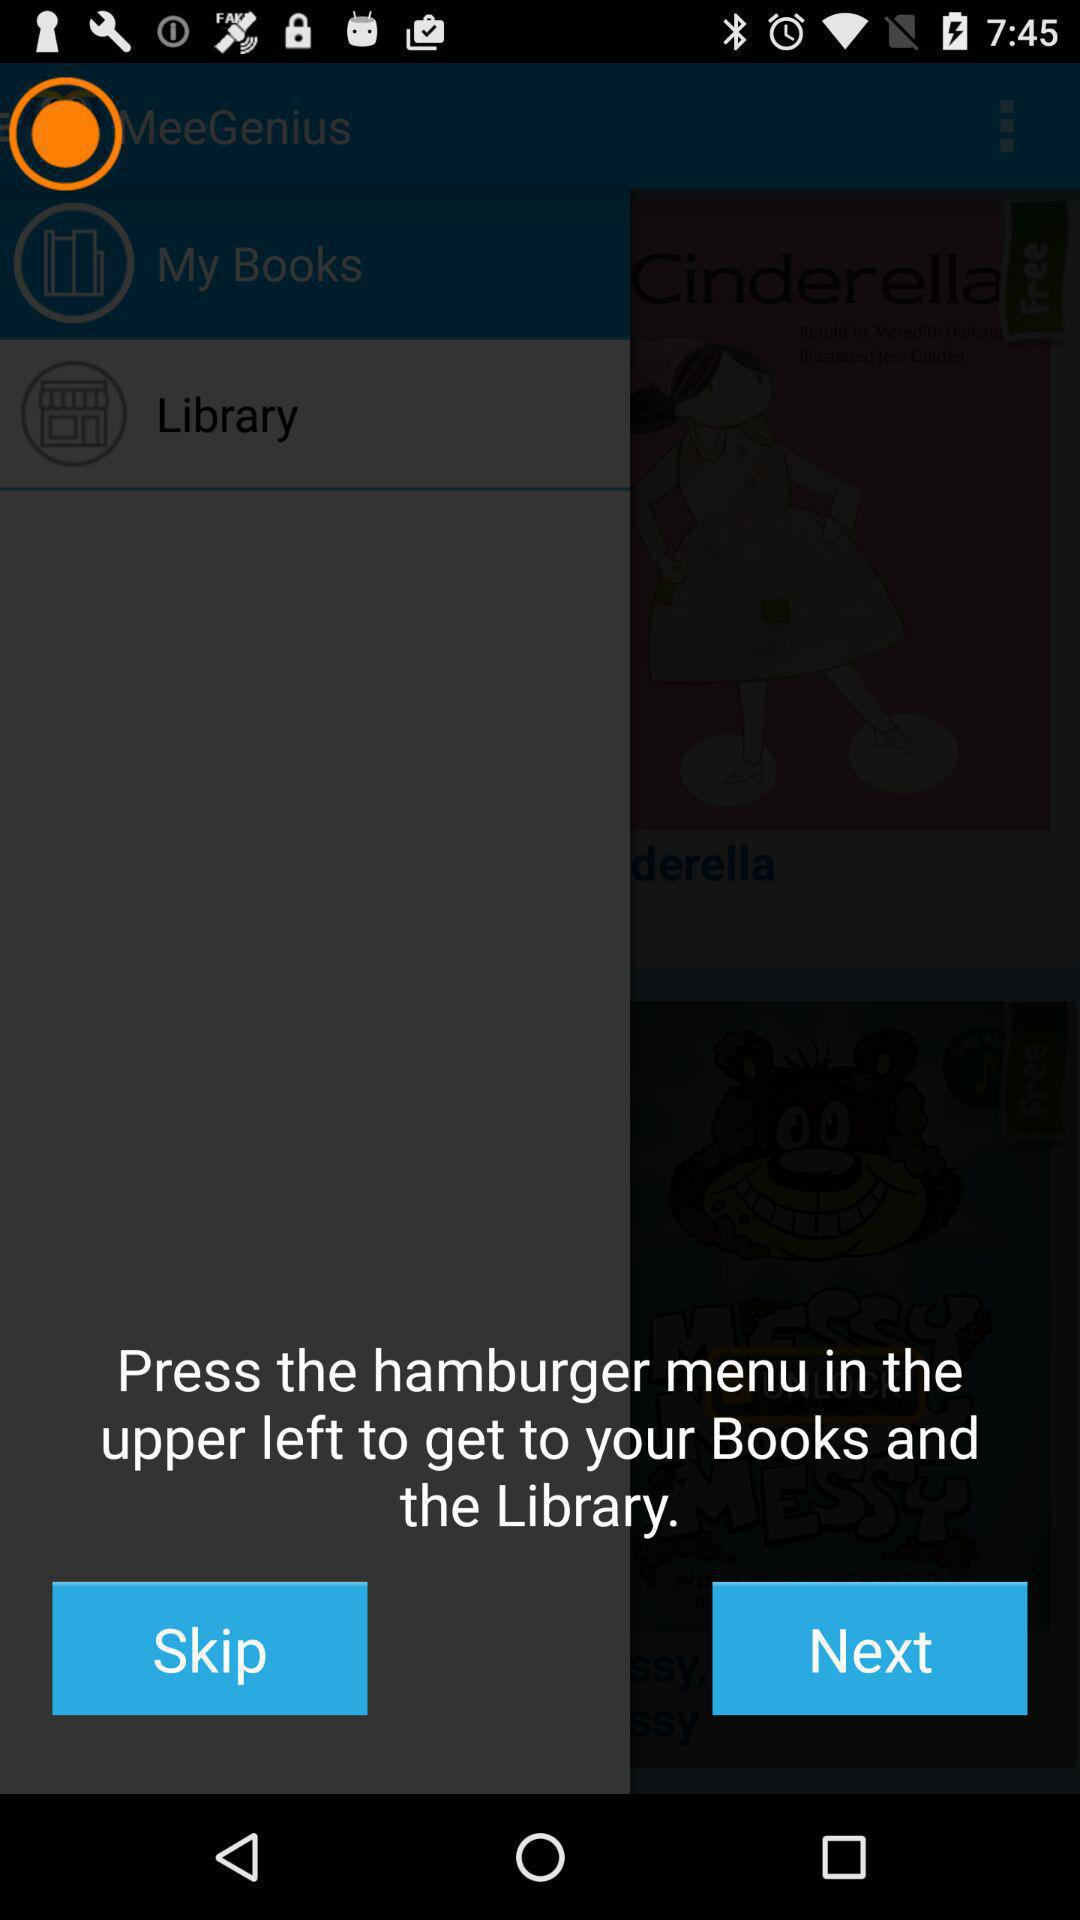What do I do to get my books and the library? To get your books and the library, press the hamburger menu in the upper left. 